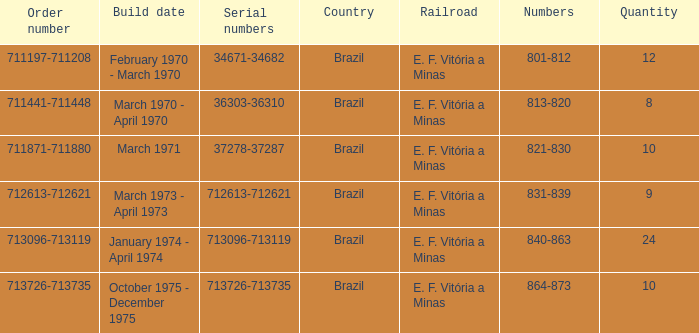What is the quantity of railroads numbered 864-873? 1.0. 